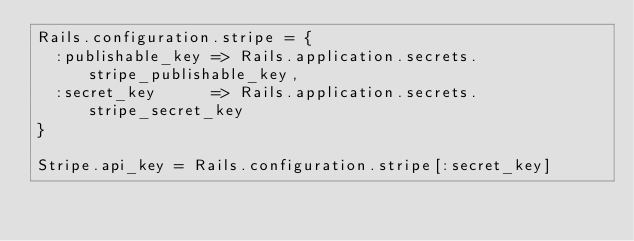Convert code to text. <code><loc_0><loc_0><loc_500><loc_500><_Ruby_>Rails.configuration.stripe = {
  :publishable_key => Rails.application.secrets.stripe_publishable_key,
  :secret_key      => Rails.application.secrets.stripe_secret_key
}

Stripe.api_key = Rails.configuration.stripe[:secret_key]</code> 